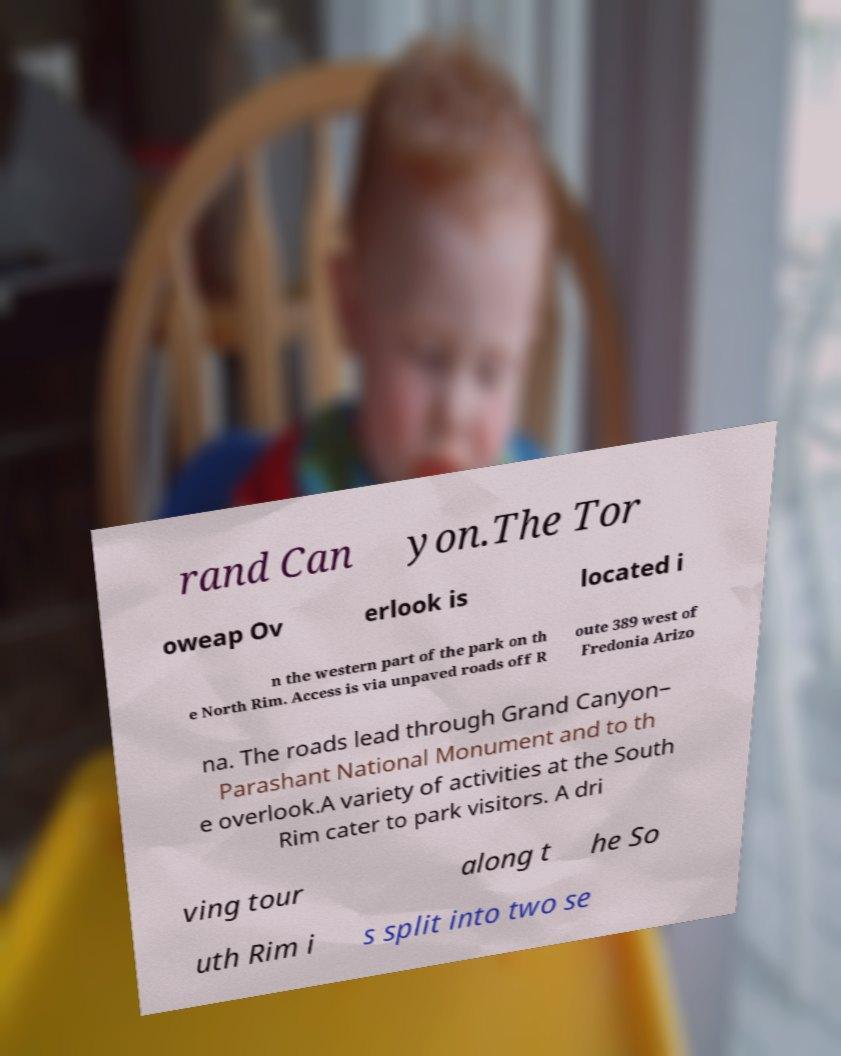Can you read and provide the text displayed in the image?This photo seems to have some interesting text. Can you extract and type it out for me? rand Can yon.The Tor oweap Ov erlook is located i n the western part of the park on th e North Rim. Access is via unpaved roads off R oute 389 west of Fredonia Arizo na. The roads lead through Grand Canyon– Parashant National Monument and to th e overlook.A variety of activities at the South Rim cater to park visitors. A dri ving tour along t he So uth Rim i s split into two se 